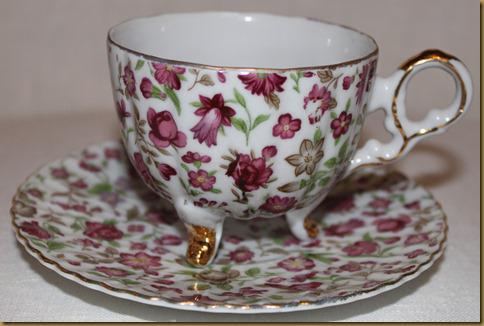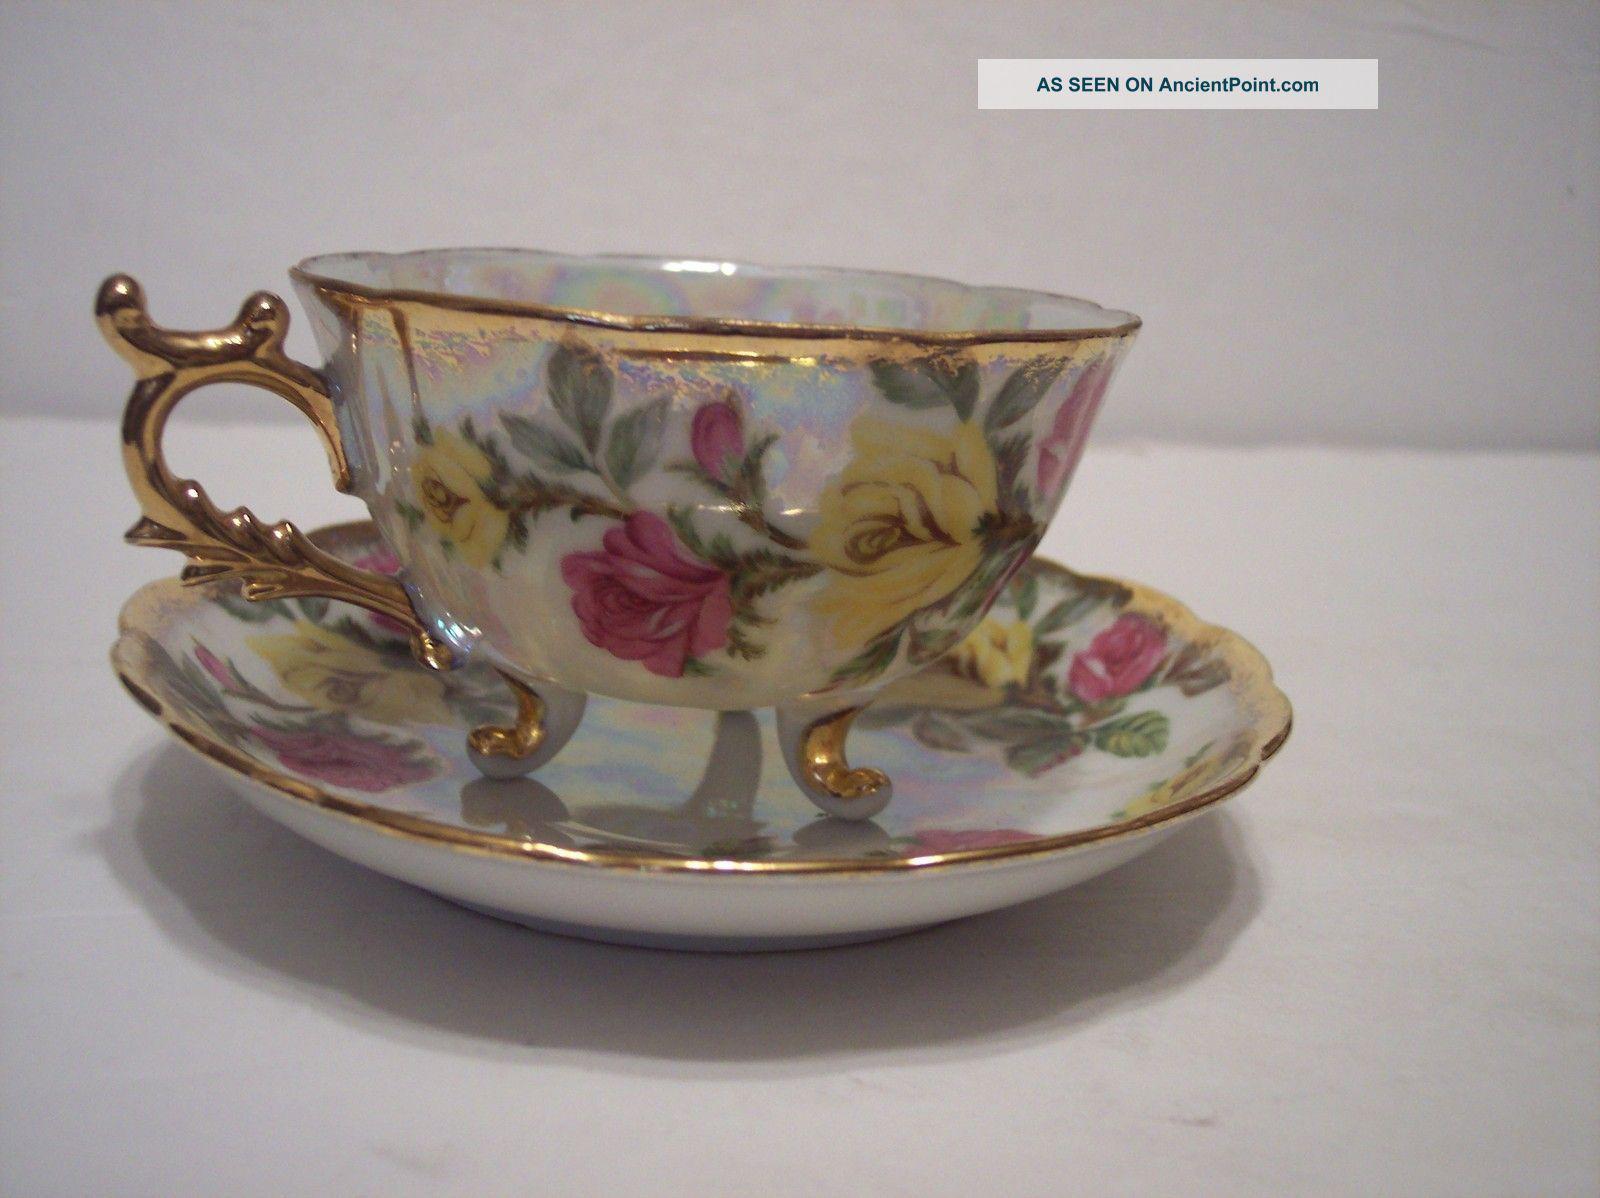The first image is the image on the left, the second image is the image on the right. Assess this claim about the two images: "The left image shows a cup and saucer with pink flowers on it.". Correct or not? Answer yes or no. Yes. The first image is the image on the left, the second image is the image on the right. Given the left and right images, does the statement "Both tea cups have curved or curled legs with gold paint." hold true? Answer yes or no. Yes. 